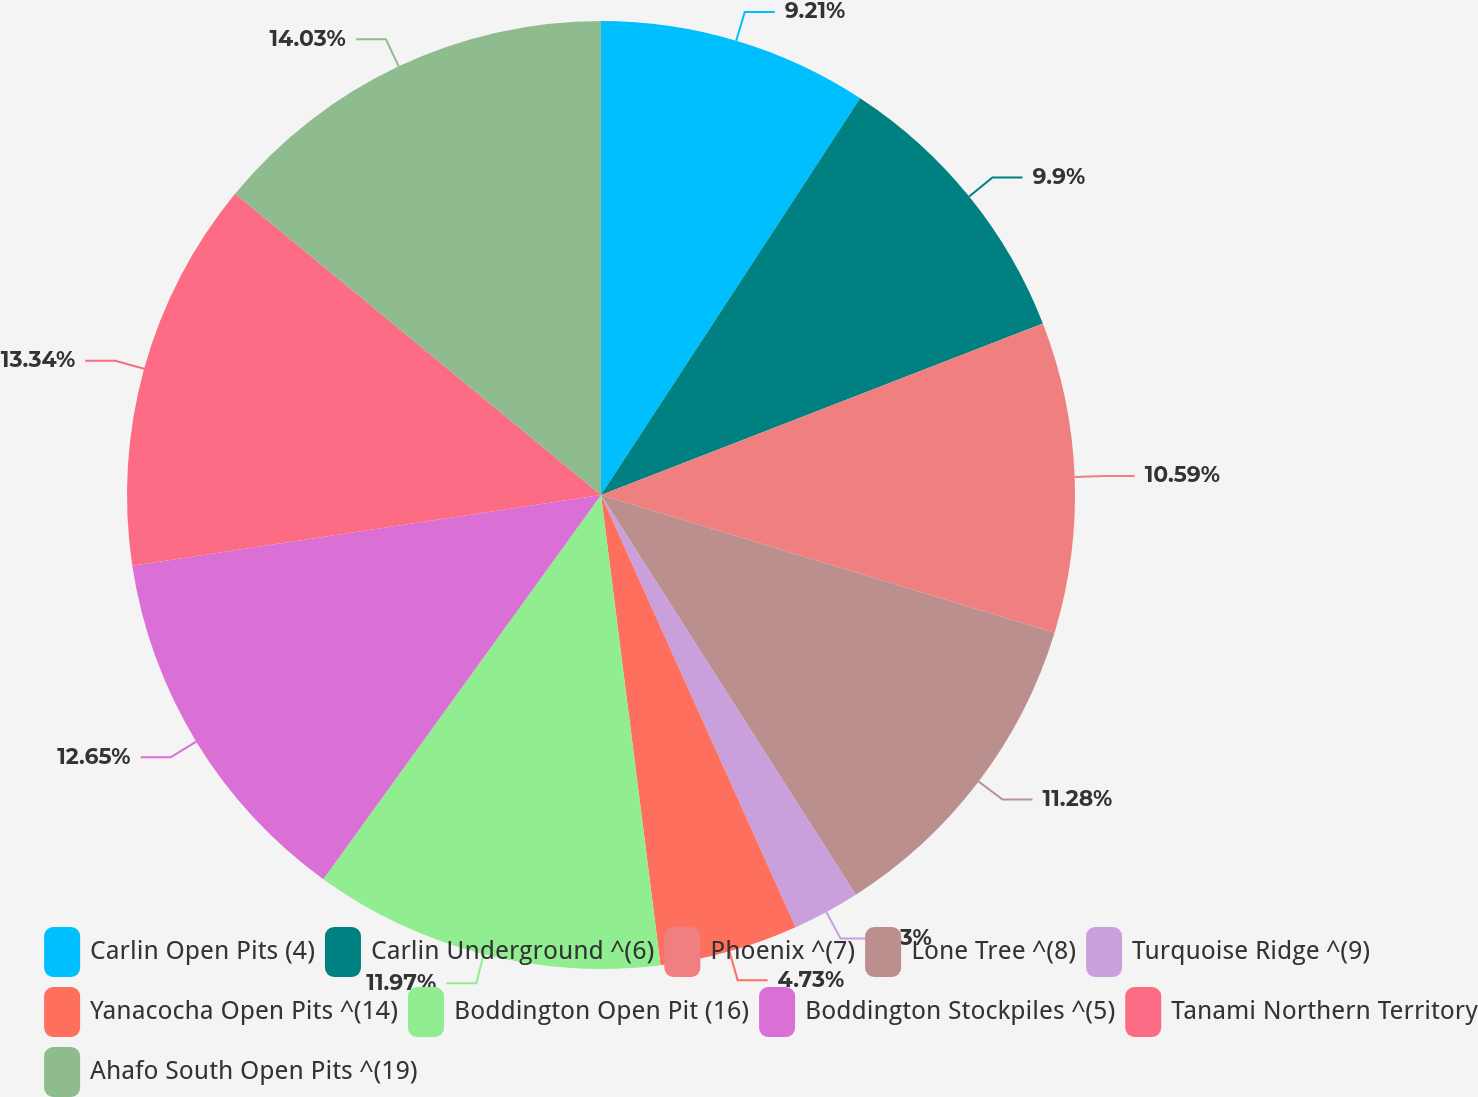Convert chart to OTSL. <chart><loc_0><loc_0><loc_500><loc_500><pie_chart><fcel>Carlin Open Pits (4)<fcel>Carlin Underground ^(6)<fcel>Phoenix ^(7)<fcel>Lone Tree ^(8)<fcel>Turquoise Ridge ^(9)<fcel>Yanacocha Open Pits ^(14)<fcel>Boddington Open Pit (16)<fcel>Boddington Stockpiles ^(5)<fcel>Tanami Northern Territory<fcel>Ahafo South Open Pits ^(19)<nl><fcel>9.21%<fcel>9.9%<fcel>10.59%<fcel>11.28%<fcel>2.3%<fcel>4.73%<fcel>11.97%<fcel>12.66%<fcel>13.35%<fcel>14.04%<nl></chart> 